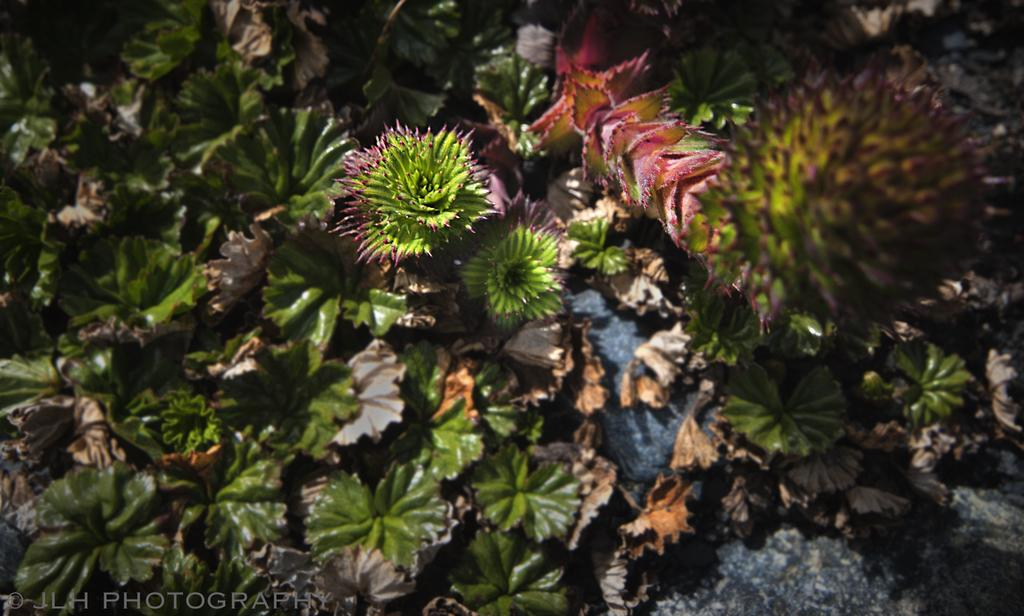What type of living organisms can be seen in the image? Plants and leaves are visible in the image. Can you describe any other objects in the image besides the plants and leaves? Yes, there is a rock in the image. Is there any text present in the image? Yes, there is text in the bottom left side of the image. What type of stamp can be seen on the leaves in the image? There is no stamp present on the leaves in the image. How many trees are visible in the image? There is no tree visible in the image; only plants and leaves are present. 